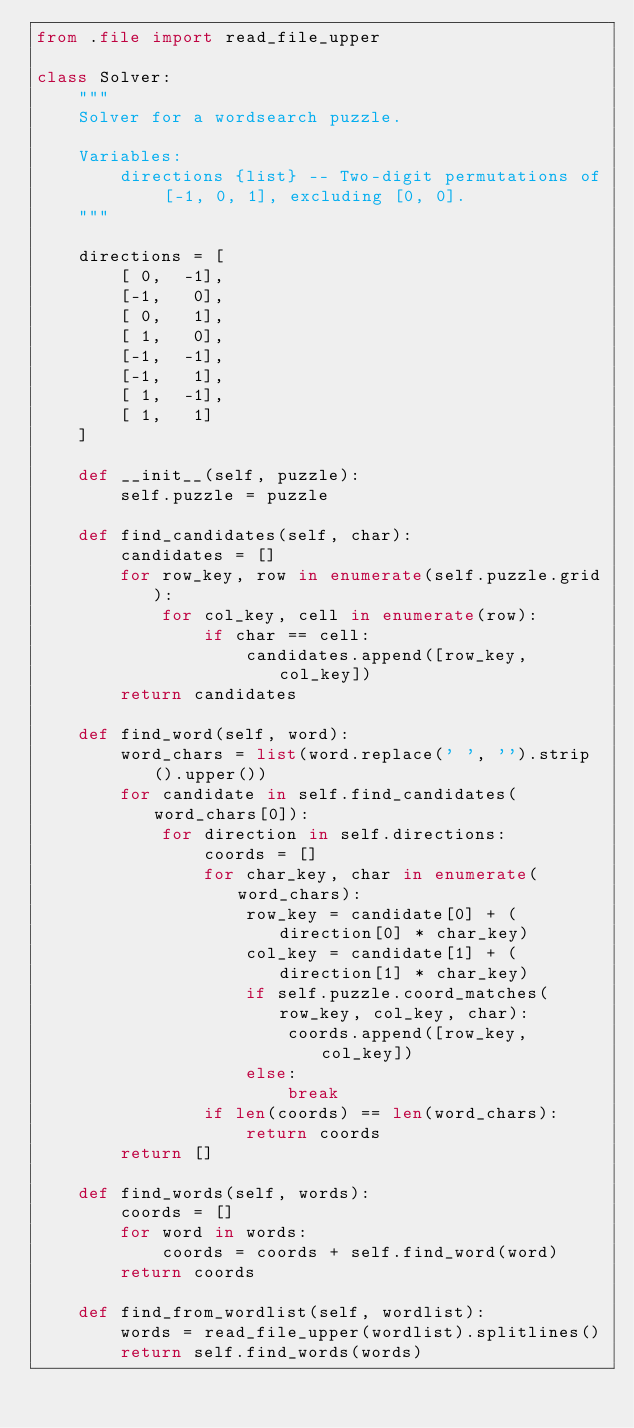Convert code to text. <code><loc_0><loc_0><loc_500><loc_500><_Python_>from .file import read_file_upper

class Solver:
    """
    Solver for a wordsearch puzzle.

    Variables:
        directions {list} -- Two-digit permutations of [-1, 0, 1], excluding [0, 0].
    """

    directions = [
        [ 0,  -1],
        [-1,   0],
        [ 0,   1],
        [ 1,   0],
        [-1,  -1],
        [-1,   1],
        [ 1,  -1],
        [ 1,   1]
    ]

    def __init__(self, puzzle):
        self.puzzle = puzzle

    def find_candidates(self, char):
        candidates = []
        for row_key, row in enumerate(self.puzzle.grid):
            for col_key, cell in enumerate(row):
                if char == cell:
                    candidates.append([row_key, col_key])
        return candidates

    def find_word(self, word):
        word_chars = list(word.replace(' ', '').strip().upper())
        for candidate in self.find_candidates(word_chars[0]):
            for direction in self.directions:
                coords = []
                for char_key, char in enumerate(word_chars):
                    row_key = candidate[0] + (direction[0] * char_key)
                    col_key = candidate[1] + (direction[1] * char_key)
                    if self.puzzle.coord_matches(row_key, col_key, char):
                        coords.append([row_key, col_key])
                    else:
                        break
                if len(coords) == len(word_chars):
                    return coords
        return []

    def find_words(self, words):
        coords = []
        for word in words:
            coords = coords + self.find_word(word)
        return coords

    def find_from_wordlist(self, wordlist):
        words = read_file_upper(wordlist).splitlines()
        return self.find_words(words)
</code> 